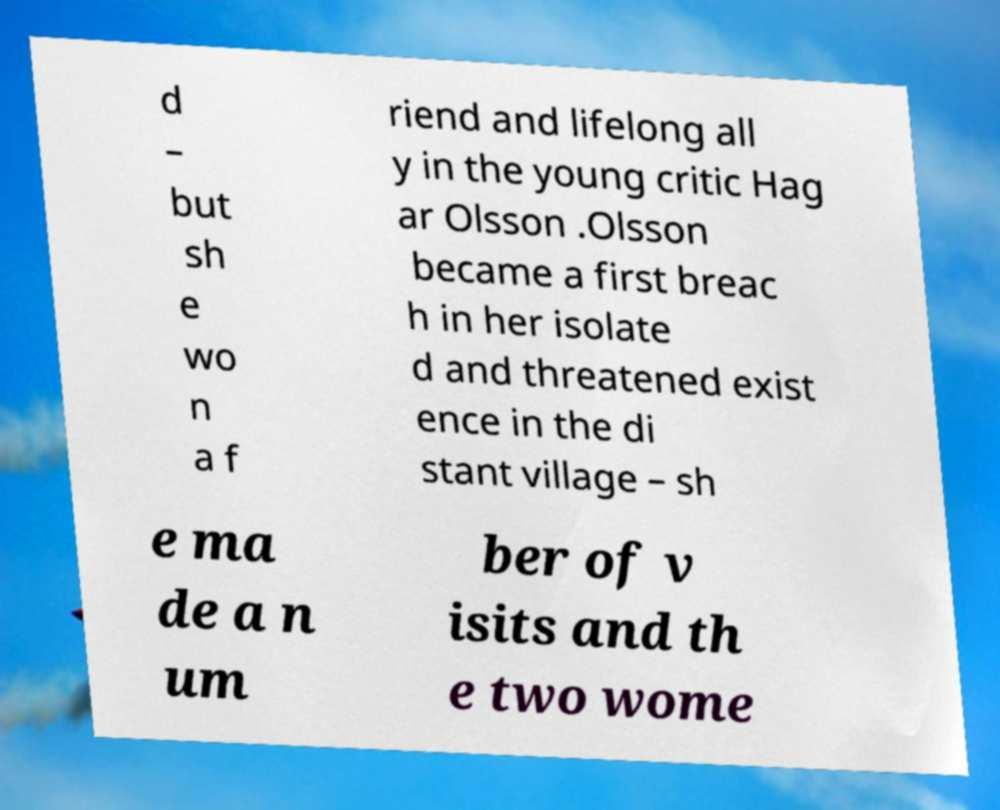Please read and relay the text visible in this image. What does it say? d – but sh e wo n a f riend and lifelong all y in the young critic Hag ar Olsson .Olsson became a first breac h in her isolate d and threatened exist ence in the di stant village – sh e ma de a n um ber of v isits and th e two wome 